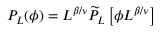<formula> <loc_0><loc_0><loc_500><loc_500>P _ { L } ( \phi ) = L ^ { \beta / \nu } \widetilde { P } _ { L } \left [ \phi L ^ { \beta / \nu } \right ]</formula> 